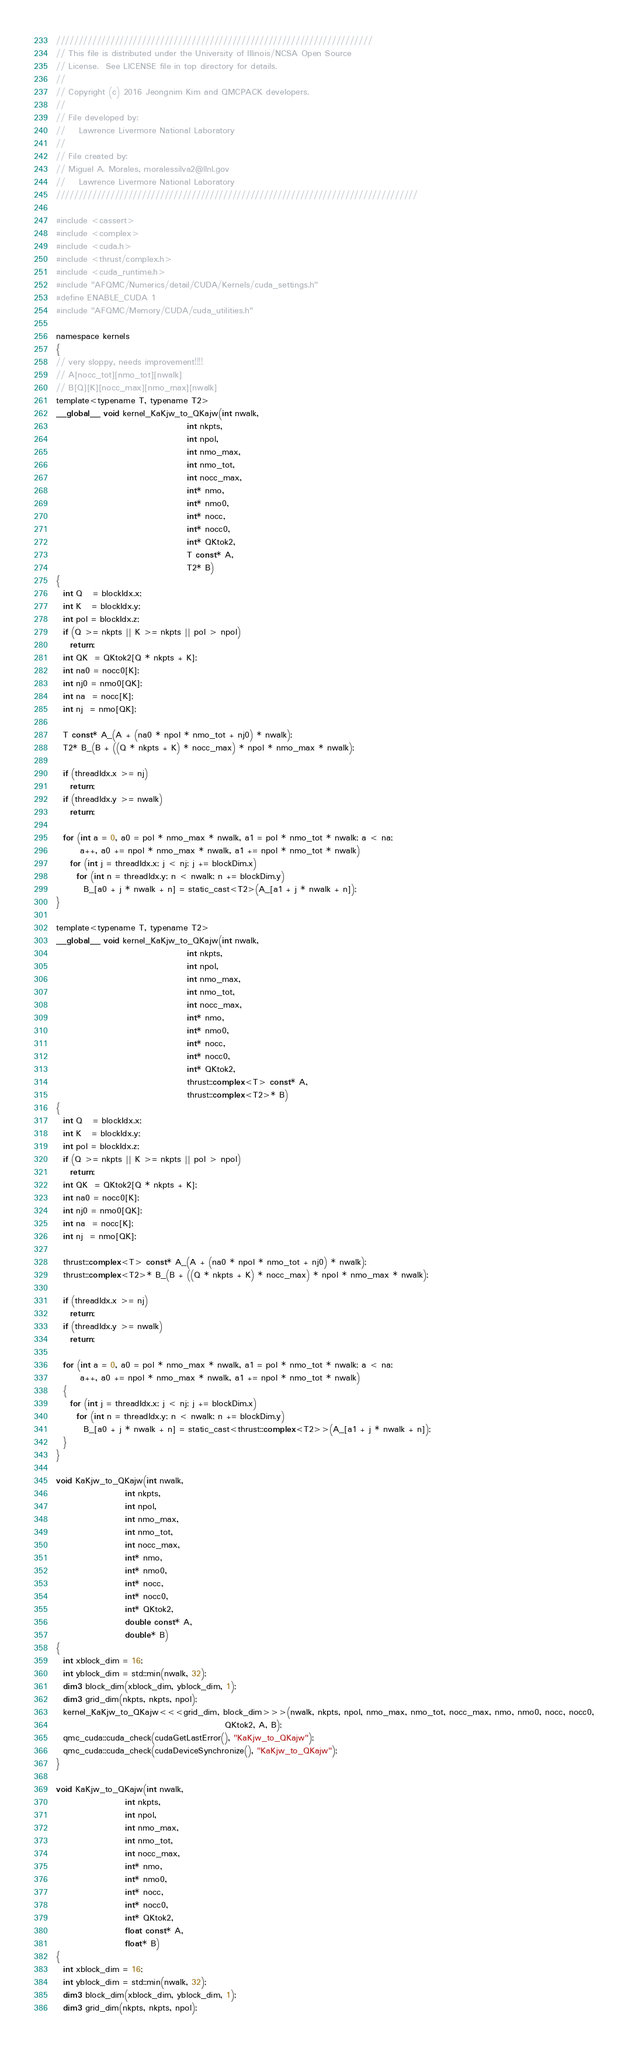<code> <loc_0><loc_0><loc_500><loc_500><_Cuda_>//////////////////////////////////////////////////////////////////////
// This file is distributed under the University of Illinois/NCSA Open Source
// License.  See LICENSE file in top directory for details.
//
// Copyright (c) 2016 Jeongnim Kim and QMCPACK developers.
//
// File developed by:
//    Lawrence Livermore National Laboratory
//
// File created by:
// Miguel A. Morales, moralessilva2@llnl.gov
//    Lawrence Livermore National Laboratory
////////////////////////////////////////////////////////////////////////////////

#include <cassert>
#include <complex>
#include <cuda.h>
#include <thrust/complex.h>
#include <cuda_runtime.h>
#include "AFQMC/Numerics/detail/CUDA/Kernels/cuda_settings.h"
#define ENABLE_CUDA 1
#include "AFQMC/Memory/CUDA/cuda_utilities.h"

namespace kernels
{
// very sloppy, needs improvement!!!!
// A[nocc_tot][nmo_tot][nwalk]
// B[Q][K][nocc_max][nmo_max][nwalk]
template<typename T, typename T2>
__global__ void kernel_KaKjw_to_QKajw(int nwalk,
                                      int nkpts,
                                      int npol,
                                      int nmo_max,
                                      int nmo_tot,
                                      int nocc_max,
                                      int* nmo,
                                      int* nmo0,
                                      int* nocc,
                                      int* nocc0,
                                      int* QKtok2,
                                      T const* A,
                                      T2* B)
{
  int Q   = blockIdx.x;
  int K   = blockIdx.y;
  int pol = blockIdx.z;
  if (Q >= nkpts || K >= nkpts || pol > npol)
    return;
  int QK  = QKtok2[Q * nkpts + K];
  int na0 = nocc0[K];
  int nj0 = nmo0[QK];
  int na  = nocc[K];
  int nj  = nmo[QK];

  T const* A_(A + (na0 * npol * nmo_tot + nj0) * nwalk);
  T2* B_(B + ((Q * nkpts + K) * nocc_max) * npol * nmo_max * nwalk);

  if (threadIdx.x >= nj)
    return;
  if (threadIdx.y >= nwalk)
    return;

  for (int a = 0, a0 = pol * nmo_max * nwalk, a1 = pol * nmo_tot * nwalk; a < na;
       a++, a0 += npol * nmo_max * nwalk, a1 += npol * nmo_tot * nwalk)
    for (int j = threadIdx.x; j < nj; j += blockDim.x)
      for (int n = threadIdx.y; n < nwalk; n += blockDim.y)
        B_[a0 + j * nwalk + n] = static_cast<T2>(A_[a1 + j * nwalk + n]);
}

template<typename T, typename T2>
__global__ void kernel_KaKjw_to_QKajw(int nwalk,
                                      int nkpts,
                                      int npol,
                                      int nmo_max,
                                      int nmo_tot,
                                      int nocc_max,
                                      int* nmo,
                                      int* nmo0,
                                      int* nocc,
                                      int* nocc0,
                                      int* QKtok2,
                                      thrust::complex<T> const* A,
                                      thrust::complex<T2>* B)
{
  int Q   = blockIdx.x;
  int K   = blockIdx.y;
  int pol = blockIdx.z;
  if (Q >= nkpts || K >= nkpts || pol > npol)
    return;
  int QK  = QKtok2[Q * nkpts + K];
  int na0 = nocc0[K];
  int nj0 = nmo0[QK];
  int na  = nocc[K];
  int nj  = nmo[QK];

  thrust::complex<T> const* A_(A + (na0 * npol * nmo_tot + nj0) * nwalk);
  thrust::complex<T2>* B_(B + ((Q * nkpts + K) * nocc_max) * npol * nmo_max * nwalk);

  if (threadIdx.x >= nj)
    return;
  if (threadIdx.y >= nwalk)
    return;

  for (int a = 0, a0 = pol * nmo_max * nwalk, a1 = pol * nmo_tot * nwalk; a < na;
       a++, a0 += npol * nmo_max * nwalk, a1 += npol * nmo_tot * nwalk)
  {
    for (int j = threadIdx.x; j < nj; j += blockDim.x)
      for (int n = threadIdx.y; n < nwalk; n += blockDim.y)
        B_[a0 + j * nwalk + n] = static_cast<thrust::complex<T2>>(A_[a1 + j * nwalk + n]);
  }
}

void KaKjw_to_QKajw(int nwalk,
                    int nkpts,
                    int npol,
                    int nmo_max,
                    int nmo_tot,
                    int nocc_max,
                    int* nmo,
                    int* nmo0,
                    int* nocc,
                    int* nocc0,
                    int* QKtok2,
                    double const* A,
                    double* B)
{
  int xblock_dim = 16;
  int yblock_dim = std::min(nwalk, 32);
  dim3 block_dim(xblock_dim, yblock_dim, 1);
  dim3 grid_dim(nkpts, nkpts, npol);
  kernel_KaKjw_to_QKajw<<<grid_dim, block_dim>>>(nwalk, nkpts, npol, nmo_max, nmo_tot, nocc_max, nmo, nmo0, nocc, nocc0,
                                                 QKtok2, A, B);
  qmc_cuda::cuda_check(cudaGetLastError(), "KaKjw_to_QKajw");
  qmc_cuda::cuda_check(cudaDeviceSynchronize(), "KaKjw_to_QKajw");
}

void KaKjw_to_QKajw(int nwalk,
                    int nkpts,
                    int npol,
                    int nmo_max,
                    int nmo_tot,
                    int nocc_max,
                    int* nmo,
                    int* nmo0,
                    int* nocc,
                    int* nocc0,
                    int* QKtok2,
                    float const* A,
                    float* B)
{
  int xblock_dim = 16;
  int yblock_dim = std::min(nwalk, 32);
  dim3 block_dim(xblock_dim, yblock_dim, 1);
  dim3 grid_dim(nkpts, nkpts, npol);</code> 